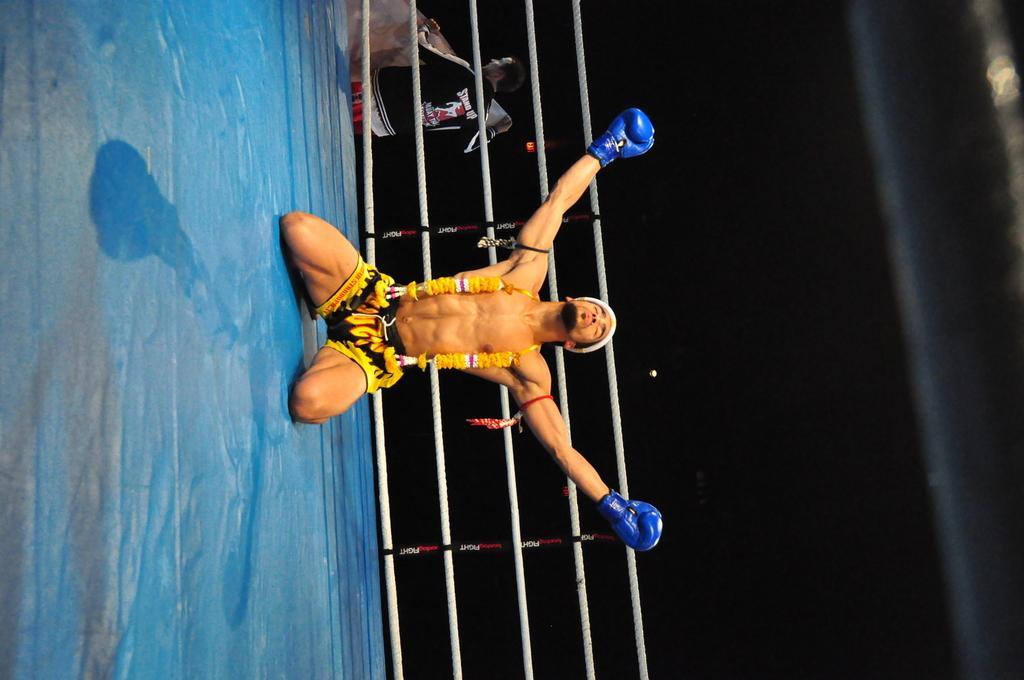In one or two sentences, can you explain what this image depicts? In this image I can see a boxing ring and in it I can see a man. I can see he is wearing a black and yellow shorts, a blue colour gloves and around his neck I can see flowers. I can also see a white thing on his head. In the background I can see few white ropes and a man. I can also see he is holding a board and on his jacket I can see something is written. 